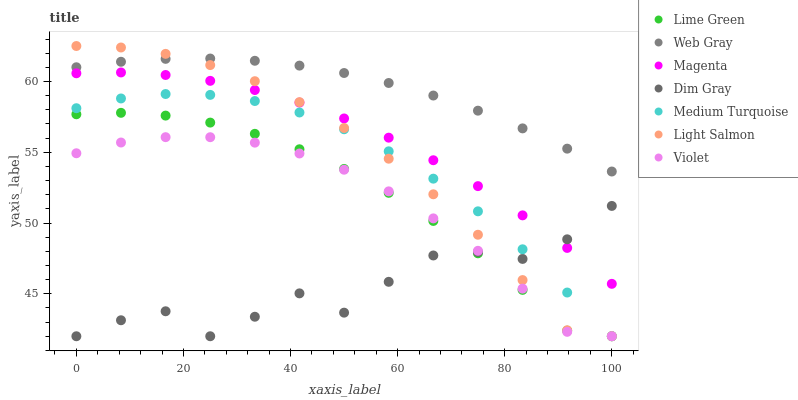Does Dim Gray have the minimum area under the curve?
Answer yes or no. Yes. Does Web Gray have the maximum area under the curve?
Answer yes or no. Yes. Does Web Gray have the minimum area under the curve?
Answer yes or no. No. Does Dim Gray have the maximum area under the curve?
Answer yes or no. No. Is Web Gray the smoothest?
Answer yes or no. Yes. Is Dim Gray the roughest?
Answer yes or no. Yes. Is Dim Gray the smoothest?
Answer yes or no. No. Is Web Gray the roughest?
Answer yes or no. No. Does Light Salmon have the lowest value?
Answer yes or no. Yes. Does Web Gray have the lowest value?
Answer yes or no. No. Does Light Salmon have the highest value?
Answer yes or no. Yes. Does Web Gray have the highest value?
Answer yes or no. No. Is Lime Green less than Web Gray?
Answer yes or no. Yes. Is Web Gray greater than Medium Turquoise?
Answer yes or no. Yes. Does Dim Gray intersect Magenta?
Answer yes or no. Yes. Is Dim Gray less than Magenta?
Answer yes or no. No. Is Dim Gray greater than Magenta?
Answer yes or no. No. Does Lime Green intersect Web Gray?
Answer yes or no. No. 